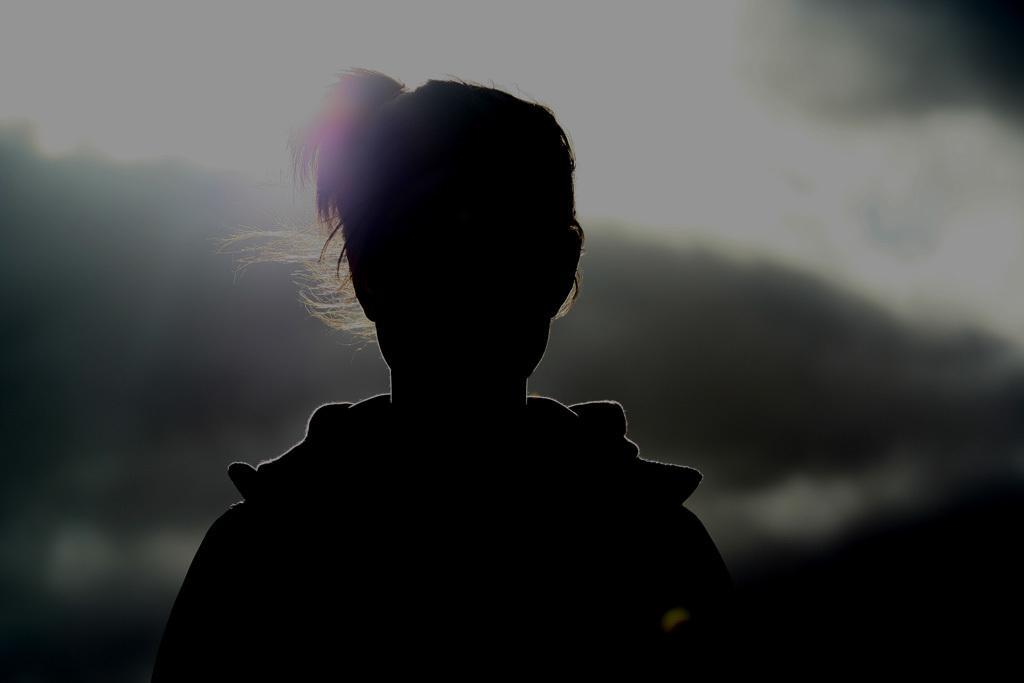In one or two sentences, can you explain what this image depicts? In this image there is a person and a blurred background. 